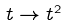<formula> <loc_0><loc_0><loc_500><loc_500>t \to t ^ { 2 }</formula> 